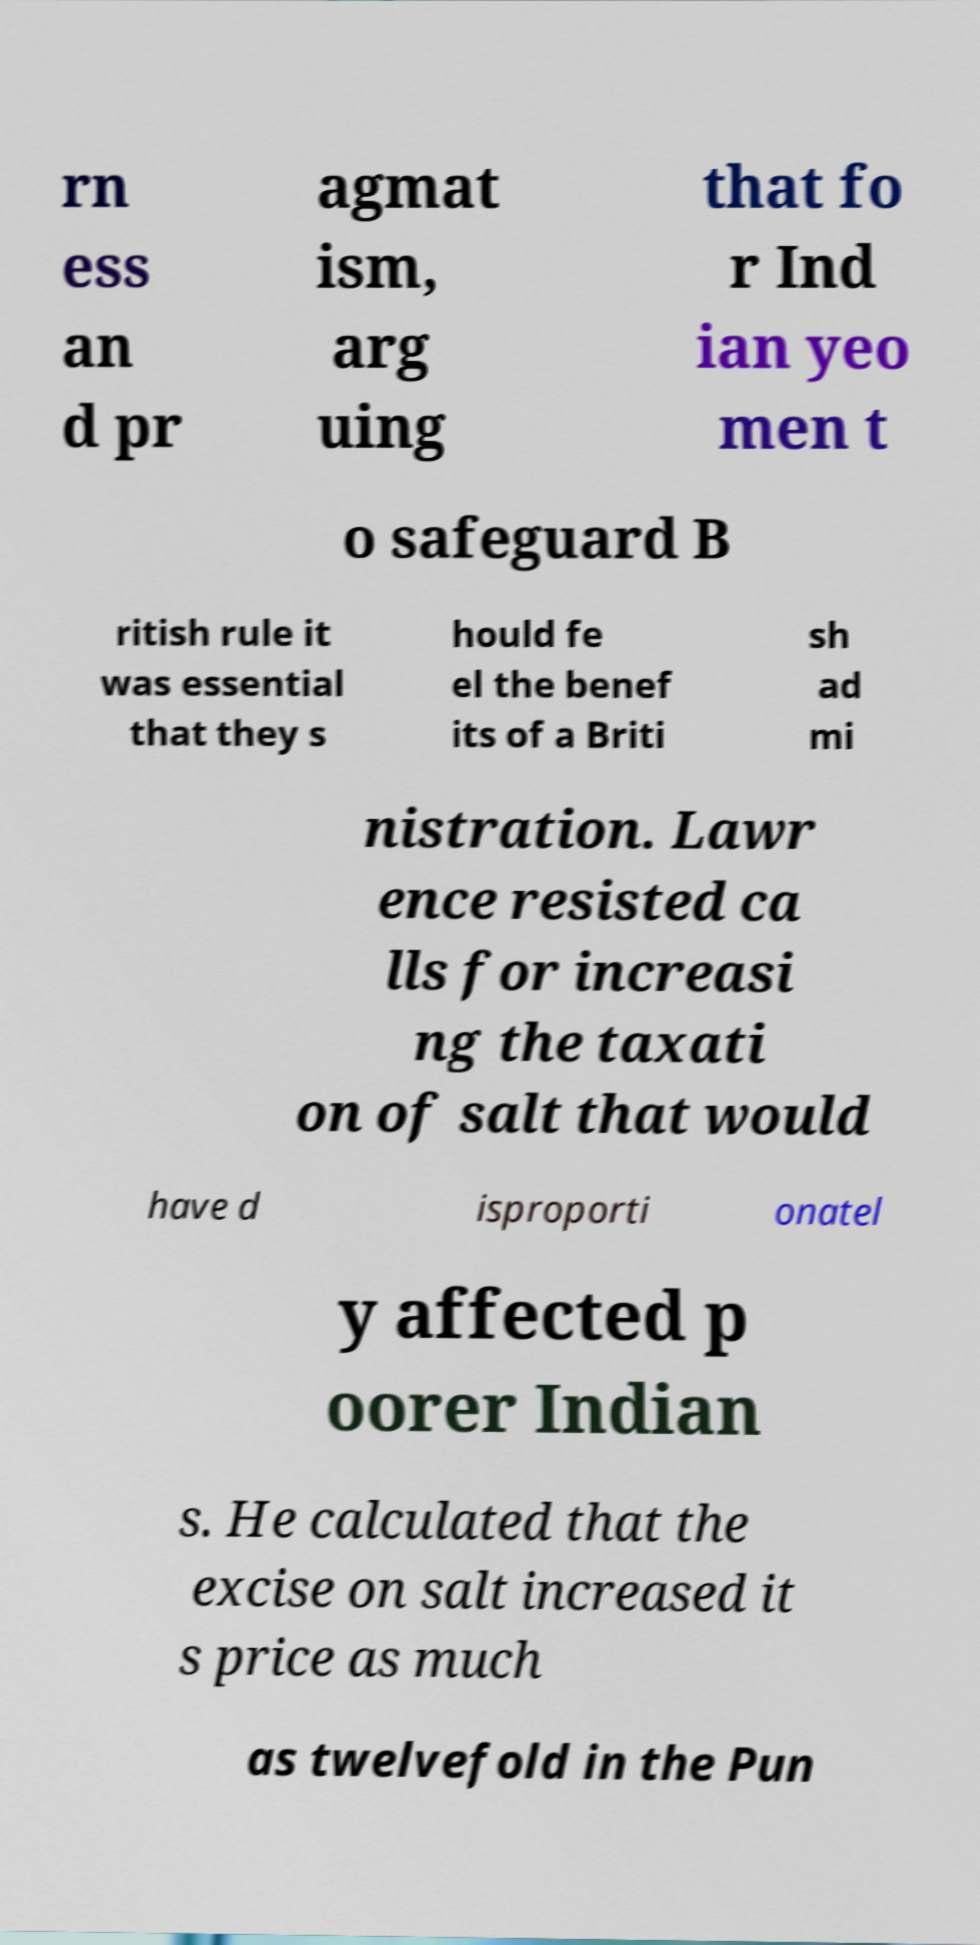What messages or text are displayed in this image? I need them in a readable, typed format. rn ess an d pr agmat ism, arg uing that fo r Ind ian yeo men t o safeguard B ritish rule it was essential that they s hould fe el the benef its of a Briti sh ad mi nistration. Lawr ence resisted ca lls for increasi ng the taxati on of salt that would have d isproporti onatel y affected p oorer Indian s. He calculated that the excise on salt increased it s price as much as twelvefold in the Pun 